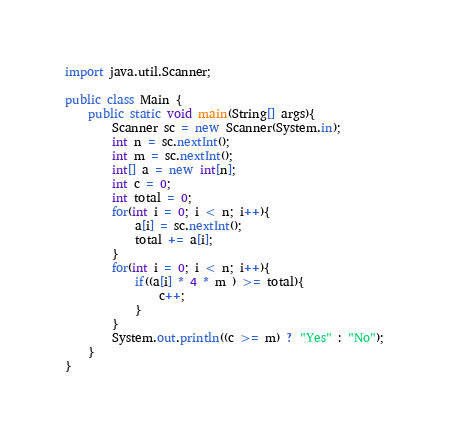<code> <loc_0><loc_0><loc_500><loc_500><_Java_>import java.util.Scanner;

public class Main {
    public static void main(String[] args){
        Scanner sc = new Scanner(System.in);
        int n = sc.nextInt();
        int m = sc.nextInt();
        int[] a = new int[n];
        int c = 0;
        int total = 0;
        for(int i = 0; i < n; i++){
            a[i] = sc.nextInt();
            total += a[i];
        }
        for(int i = 0; i < n; i++){
            if((a[i] * 4 * m ) >= total){
                c++;
            }
        }
        System.out.println((c >= m) ? "Yes" : "No");
    }
}</code> 